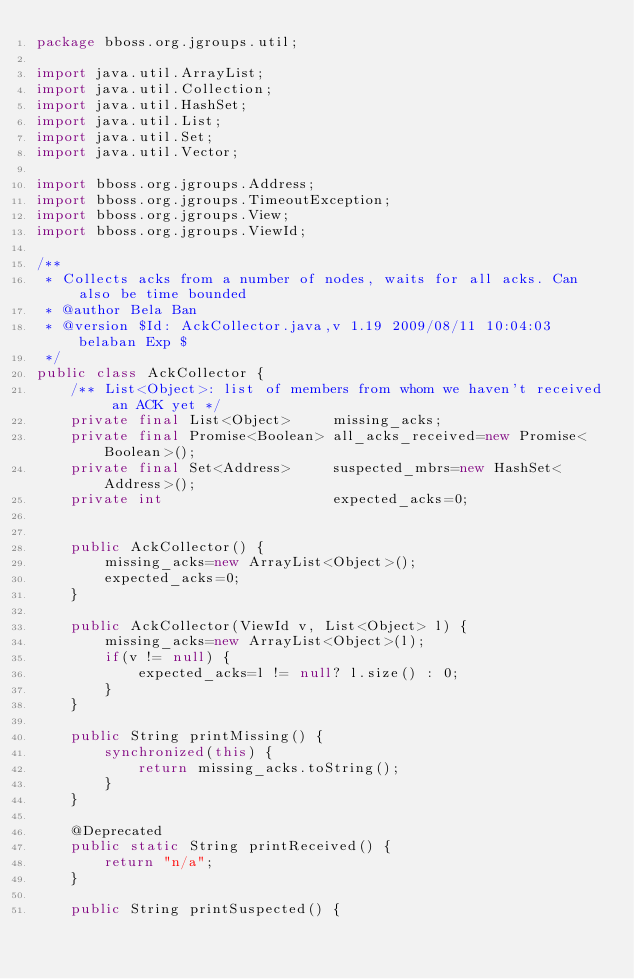Convert code to text. <code><loc_0><loc_0><loc_500><loc_500><_Java_>package bboss.org.jgroups.util;

import java.util.ArrayList;
import java.util.Collection;
import java.util.HashSet;
import java.util.List;
import java.util.Set;
import java.util.Vector;

import bboss.org.jgroups.Address;
import bboss.org.jgroups.TimeoutException;
import bboss.org.jgroups.View;
import bboss.org.jgroups.ViewId;

/**
 * Collects acks from a number of nodes, waits for all acks. Can also be time bounded
 * @author Bela Ban
 * @version $Id: AckCollector.java,v 1.19 2009/08/11 10:04:03 belaban Exp $
 */
public class AckCollector {
    /** List<Object>: list of members from whom we haven't received an ACK yet */
    private final List<Object>     missing_acks;
    private final Promise<Boolean> all_acks_received=new Promise<Boolean>();
    private final Set<Address>     suspected_mbrs=new HashSet<Address>();
    private int                    expected_acks=0;


    public AckCollector() {
        missing_acks=new ArrayList<Object>();
        expected_acks=0;
    }

    public AckCollector(ViewId v, List<Object> l) {
        missing_acks=new ArrayList<Object>(l);
        if(v != null) {
            expected_acks=l != null? l.size() : 0;
        }
    }

    public String printMissing() {
        synchronized(this) {
            return missing_acks.toString();
        }
    }

    @Deprecated
    public static String printReceived() {
        return "n/a";
    }

    public String printSuspected() {</code> 